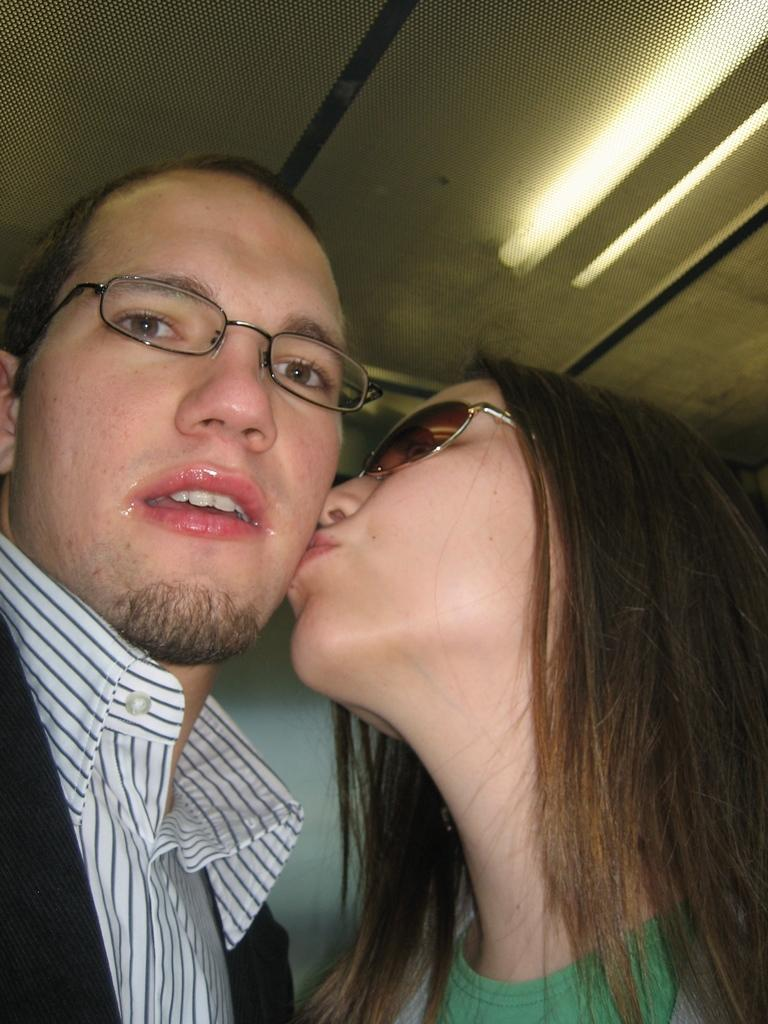How many people are in the foreground of the picture? There are two people, a man and a woman, in the foreground of the picture. What is the woman doing to the man in the picture? The woman is kissing the man on the cheek in the picture. What can be seen in the background of the picture? There are lights on the ceiling in the background of the picture. Where is the key located in the picture? There is no key present in the picture. Can you see a monkey in the picture? No, there is no monkey present in the picture. 